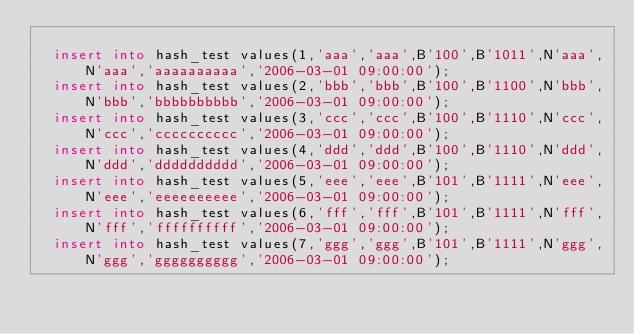Convert code to text. <code><loc_0><loc_0><loc_500><loc_500><_SQL_>
	insert into hash_test values(1,'aaa','aaa',B'100',B'1011',N'aaa',N'aaa','aaaaaaaaaa','2006-03-01 09:00:00');
	insert into hash_test values(2,'bbb','bbb',B'100',B'1100',N'bbb',N'bbb','bbbbbbbbbb','2006-03-01 09:00:00');
	insert into hash_test values(3,'ccc','ccc',B'100',B'1110',N'ccc',N'ccc','cccccccccc','2006-03-01 09:00:00');
	insert into hash_test values(4,'ddd','ddd',B'100',B'1110',N'ddd',N'ddd','dddddddddd','2006-03-01 09:00:00');
	insert into hash_test values(5,'eee','eee',B'101',B'1111',N'eee',N'eee','eeeeeeeeee','2006-03-01 09:00:00');
	insert into hash_test values(6,'fff','fff',B'101',B'1111',N'fff',N'fff','ffffffffff','2006-03-01 09:00:00');
	insert into hash_test values(7,'ggg','ggg',B'101',B'1111',N'ggg',N'ggg','gggggggggg','2006-03-01 09:00:00');</code> 